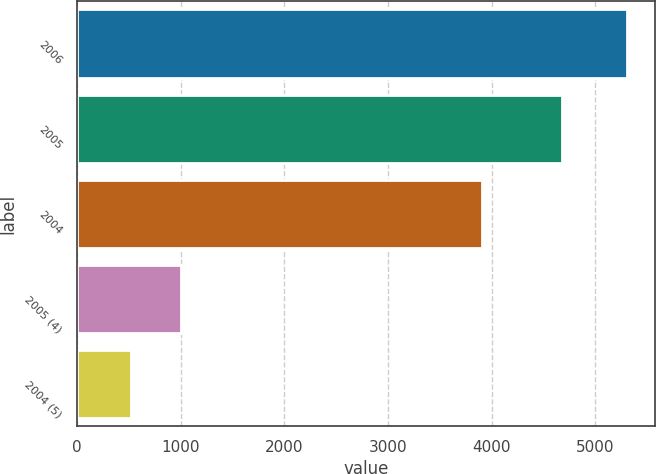<chart> <loc_0><loc_0><loc_500><loc_500><bar_chart><fcel>2006<fcel>2005<fcel>2004<fcel>2005 (4)<fcel>2004 (5)<nl><fcel>5306<fcel>4680<fcel>3910<fcel>1000.4<fcel>522<nl></chart> 